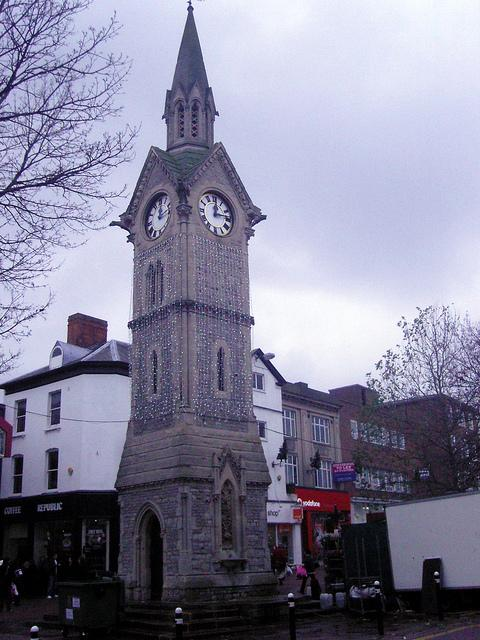What is near the apex of the tower? Please explain your reasoning. clock. The round feature with roman numerals around the edge is a clock. 